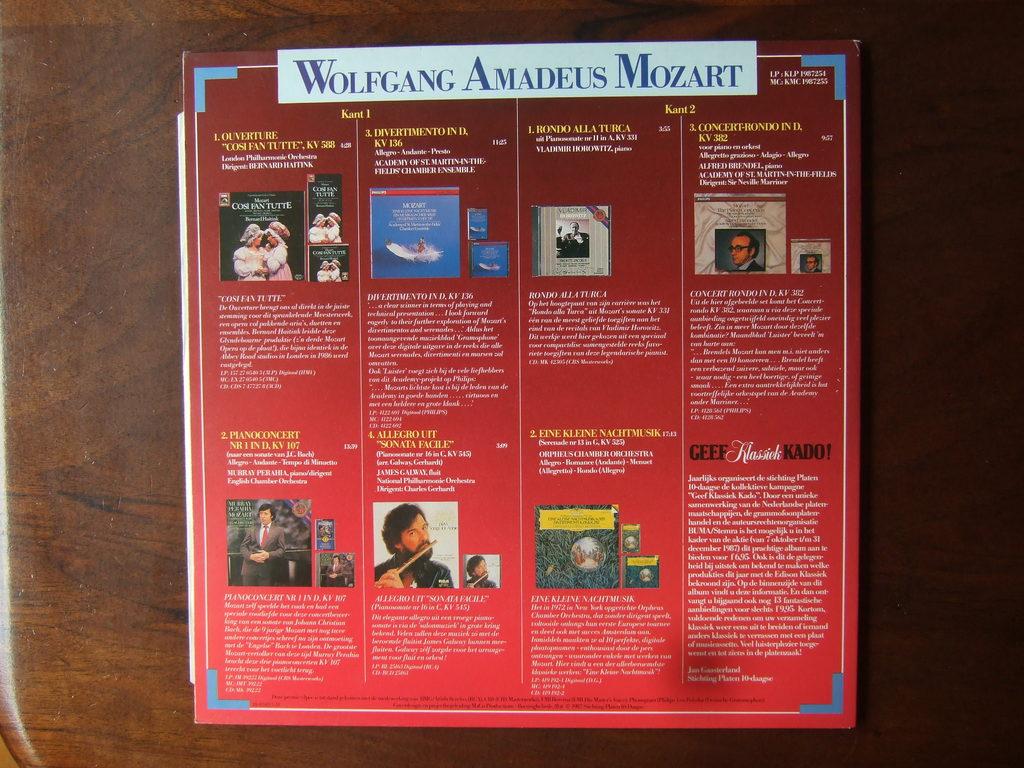What famous composer is this about?
Provide a succinct answer. Wolfgang amadeus mozart. What is the first letter of the first name at the top?
Your answer should be very brief. W. 